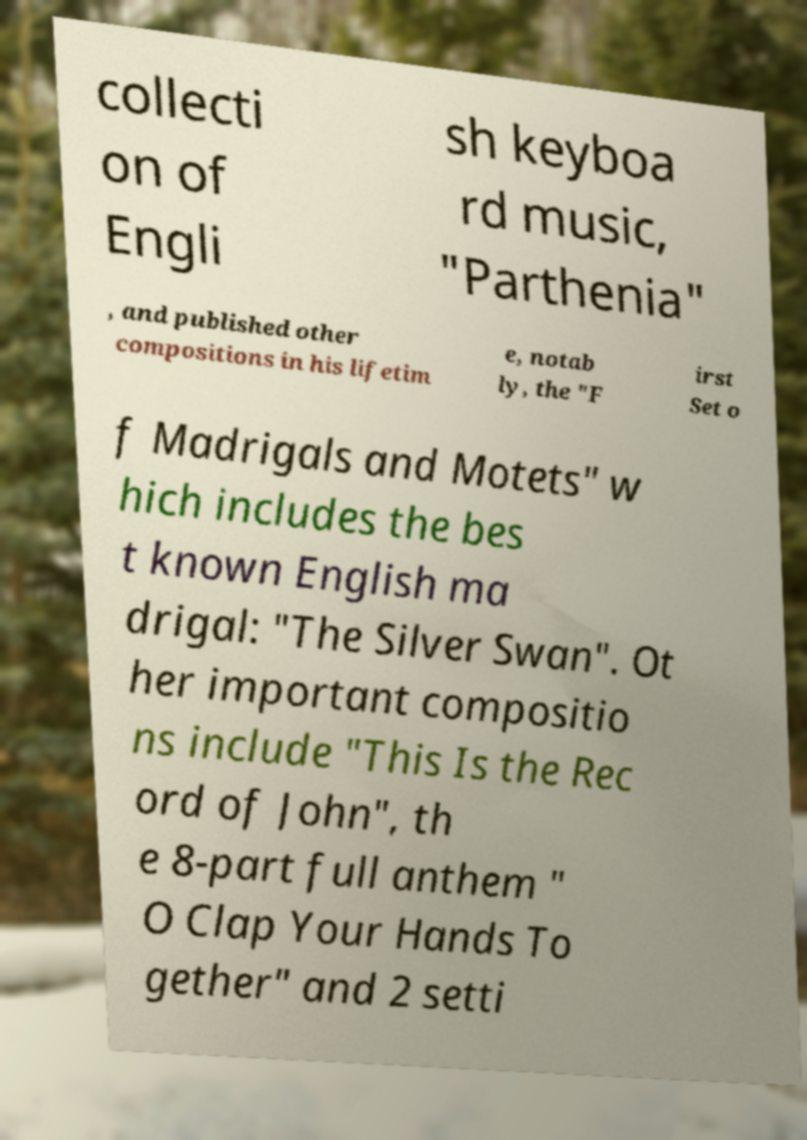There's text embedded in this image that I need extracted. Can you transcribe it verbatim? collecti on of Engli sh keyboa rd music, "Parthenia" , and published other compositions in his lifetim e, notab ly, the "F irst Set o f Madrigals and Motets" w hich includes the bes t known English ma drigal: "The Silver Swan". Ot her important compositio ns include "This Is the Rec ord of John", th e 8-part full anthem " O Clap Your Hands To gether" and 2 setti 